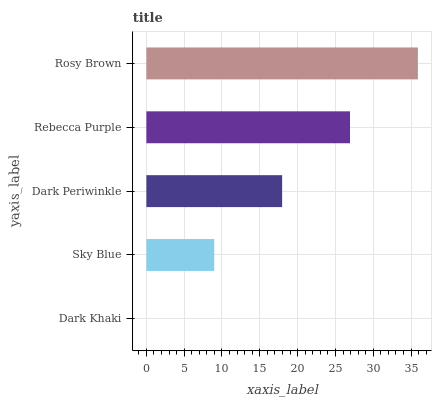Is Dark Khaki the minimum?
Answer yes or no. Yes. Is Rosy Brown the maximum?
Answer yes or no. Yes. Is Sky Blue the minimum?
Answer yes or no. No. Is Sky Blue the maximum?
Answer yes or no. No. Is Sky Blue greater than Dark Khaki?
Answer yes or no. Yes. Is Dark Khaki less than Sky Blue?
Answer yes or no. Yes. Is Dark Khaki greater than Sky Blue?
Answer yes or no. No. Is Sky Blue less than Dark Khaki?
Answer yes or no. No. Is Dark Periwinkle the high median?
Answer yes or no. Yes. Is Dark Periwinkle the low median?
Answer yes or no. Yes. Is Rosy Brown the high median?
Answer yes or no. No. Is Rosy Brown the low median?
Answer yes or no. No. 